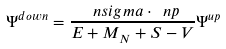Convert formula to latex. <formula><loc_0><loc_0><loc_500><loc_500>\Psi ^ { d o w n } = \frac { \ n s i g m a \cdot \ n p } { E + M _ { N } + S - V } \Psi ^ { u p }</formula> 